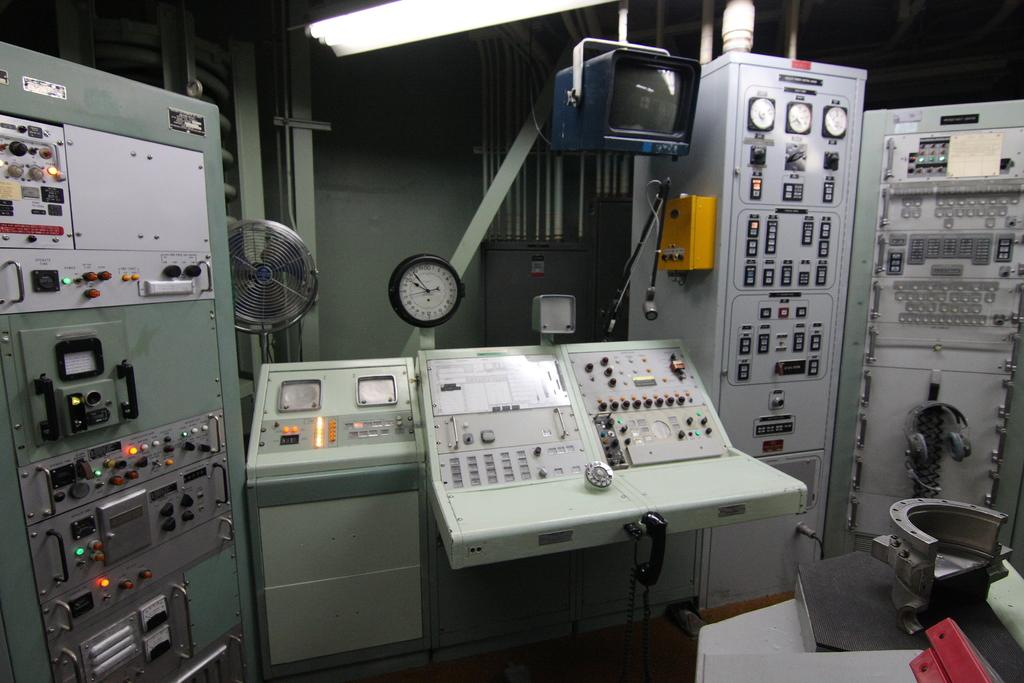What type of device is visible in the image? There is a table fan in the image. What is used for amplifying sound in the image? There is a microphone with a microphone stand in the image. What type of electronic device is present in the image? There is a television in the image. What is used for communication in the image? There is a headset in the image. What type of equipment is present in the image? There are machines in the image. How many horses can be seen running in the image? There are no horses present in the image. What type of heat source is visible in the image? There is no heat source visible in the image. 